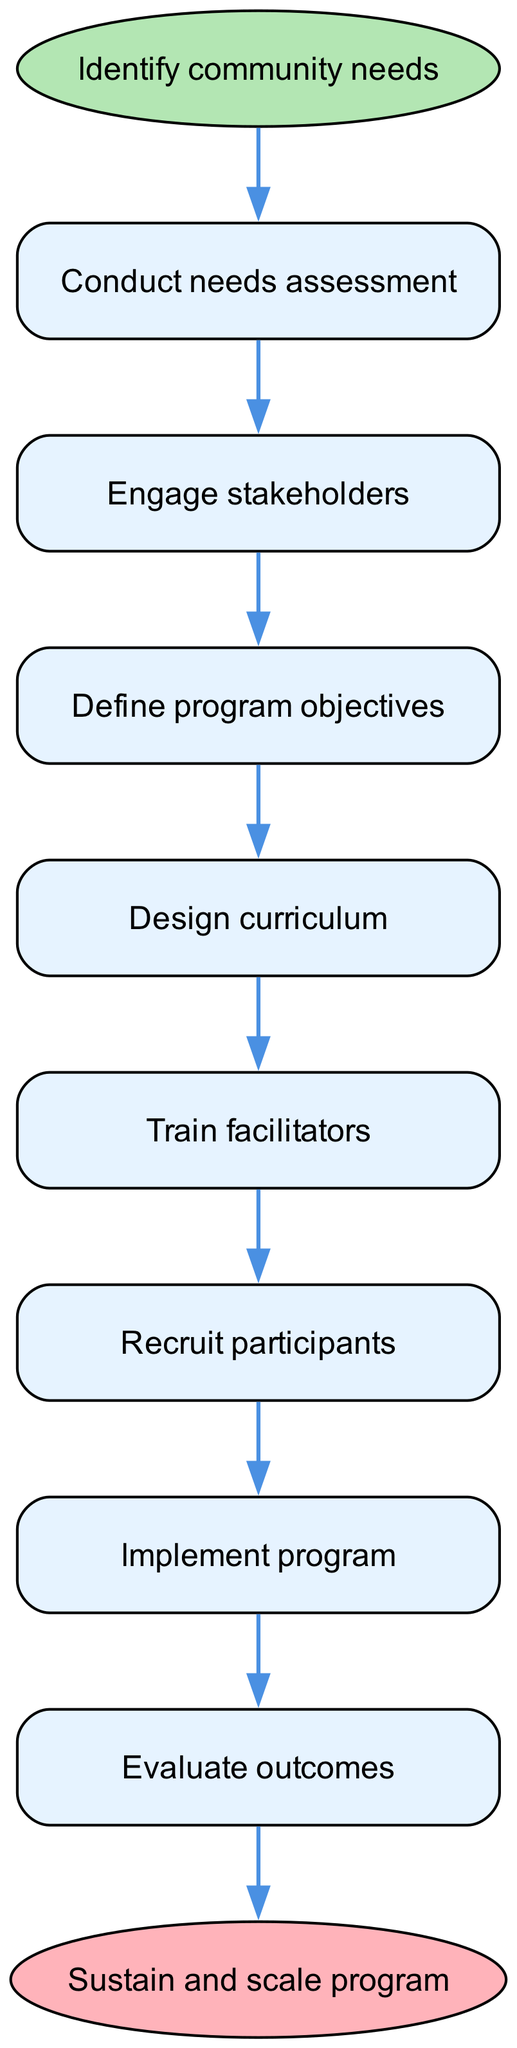What is the first step in the diagram? The first step in the diagram is indicated as the starting point, which is "Identify community needs."
Answer: Identify community needs How many steps are there in the process? There are a total of 8 steps listed in the diagram, progressing from identifying community needs to refining and adapting the program.
Answer: 8 What is the last step before the endpoint? The last step before the endpoint is "Evaluate outcomes," which connects to the final point of sustaining and scaling the program.
Answer: Evaluate outcomes Which step follows "Engage stakeholders"? The step that follows "Engage stakeholders" is "Define program objectives," indicating the progress in the flow of the program design.
Answer: Define program objectives What is the relationship between "Train facilitators" and "Recruit participants"? "Train facilitators" directly precedes "Recruit participants," indicating that training is necessary before participant recruitment can occur.
Answer: Directly precedes How do we reach the endpoint from "Implement program"? From "Implement program," the flow leads directly to the evaluation of outcomes, which then connects to the endpoint of sustaining and scaling the program.
Answer: Evaluate outcomes What is the shape of the start node? The start node is shaped like an ellipse, distinguishing it visually from the other steps, which are rectangular.
Answer: Ellipse What happens after "Refine and adapt"? "Refine and adapt" does not transition to another step but leads to the endpoint where the program is sustained and scaled.
Answer: Sustain and scale program 